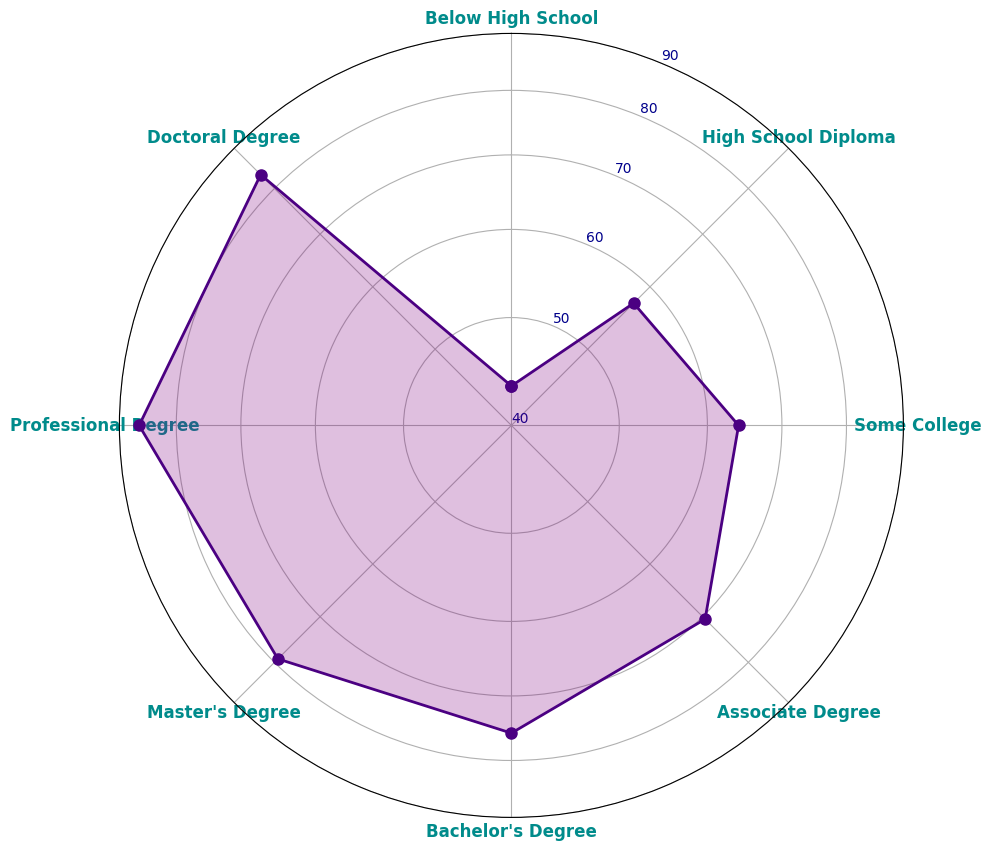What's the employment rate for individuals with a Master's degree? The employment rate for individuals with a Master's degree can be found directly on the radar chart by looking at the point labeled "Master's Degree". According to the chart, the employment rate is 79.2%.
Answer: 79.2% Which educational degree level has the highest employment rate? To determine which level has the highest employment rate, look for the point that is farthest from the center on the radar chart. The highest value is 86.4% for "Professional Degree".
Answer: Professional Degree Is the employment rate for individuals with an Associate Degree higher or lower than those with a High School Diploma? Compare the points labeled "Associate Degree" and "High School Diploma" on the radar chart. The Associate Degree (70.5%) has a higher employment rate than the High School Diploma (57.2%).
Answer: Higher What is the difference in employment rates between individuals with a Bachelor's degree and those with Some College? Locate the points for "Bachelor's Degree" (75.6%) and "Some College" (64.0%). Subtract the employment rate of Some College from that of Bachelor's Degree: 75.6% - 64.0% = 11.6%.
Answer: 11.6% What's the average employment rate for degree levels above a Bachelor's degree (Master's, Professional, Doctoral)? Add the employment rates for Master's (79.2%), Professional (86.4%), and Doctoral (83.3%) degrees, then divide by the number of degree levels: (79.2 + 86.4 + 83.3) / 3 = 83.0.
Answer: 83.0 How many degree levels have an employment rate greater than 70%? Identify the points on the radar chart with an employment rate above 70%: Some College (64.0%) is not above 70%, while Associate (70.5%), Bachelor's (75.6%), Master's (79.2%), Professional (86.4%), and Doctoral (83.3%) are. Count these points: 5 degree levels.
Answer: 5 Compare the employment rates of the lowest and highest degree levels and state the percentage difference. Identify the lowest (Below High School: 43.4%) and highest (Professional Degree: 86.4%) rates. The percentage difference can be calculated as (86.4 - 43.4) = 43.0%.
Answer: 43.0% Which degree level has an employment rate closest to 80%? Locate the point on the radar chart near 80%. The closest degree level to 80% is Master's Degree at 79.2%.
Answer: Master's Degree 